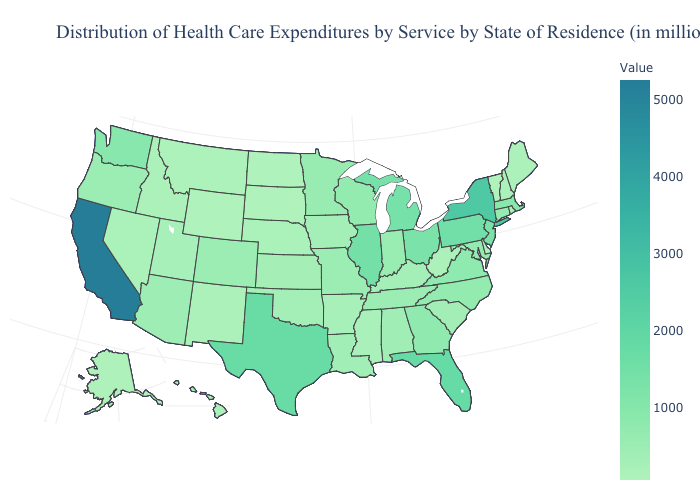Does California have the highest value in the USA?
Short answer required. Yes. Does California have the highest value in the USA?
Keep it brief. Yes. Does California have the highest value in the West?
Answer briefly. Yes. Does Illinois have the highest value in the MidWest?
Give a very brief answer. Yes. Does Mississippi have the highest value in the USA?
Answer briefly. No. 